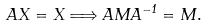Convert formula to latex. <formula><loc_0><loc_0><loc_500><loc_500>A X = X \Longrightarrow A M A ^ { - 1 } = M .</formula> 